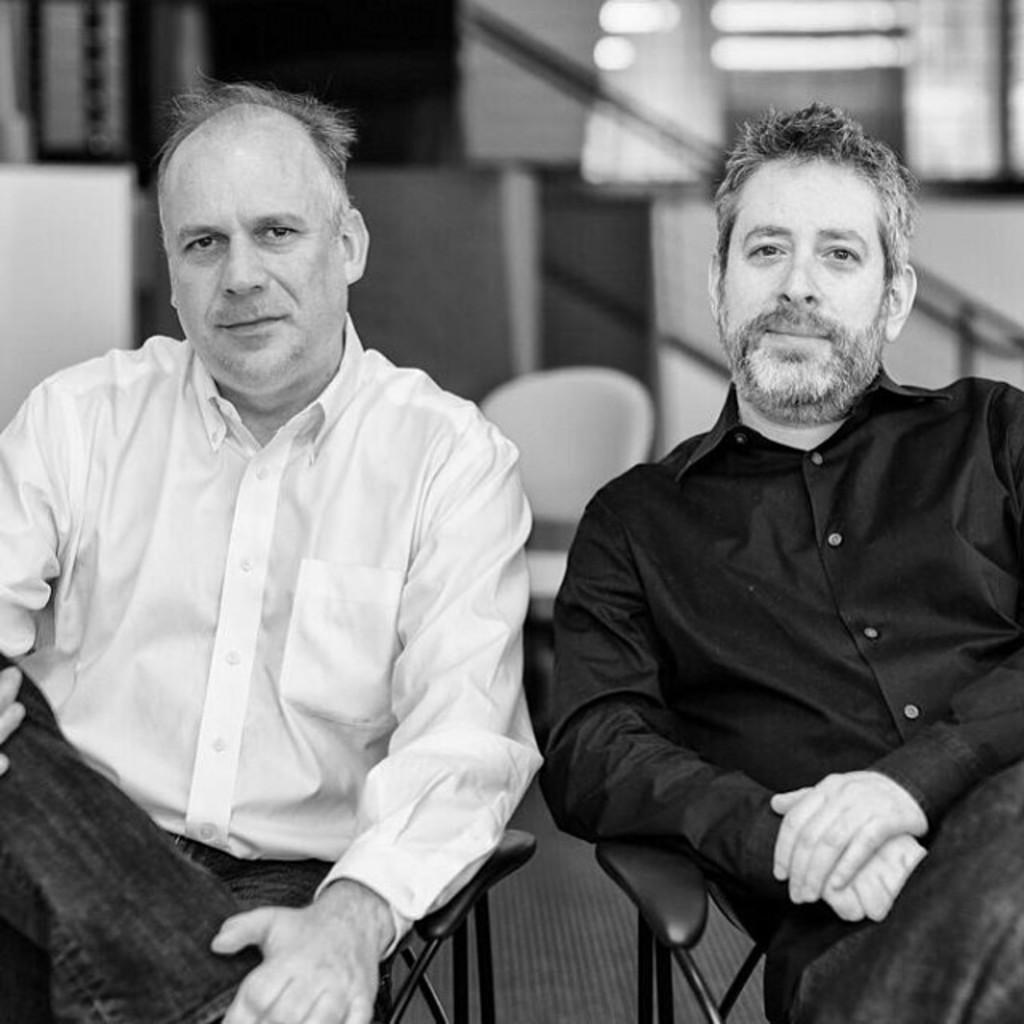Please provide a concise description of this image. In this image we can see two persons sitting on the chair, behind them there is another chair, also we can see the wall, and the background is blurred, the picture is taken in black and white mode. 